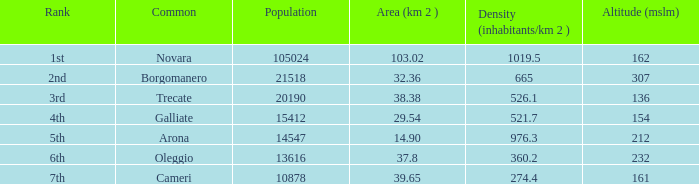Which common possesses an area (km2) of 10 Novara. 